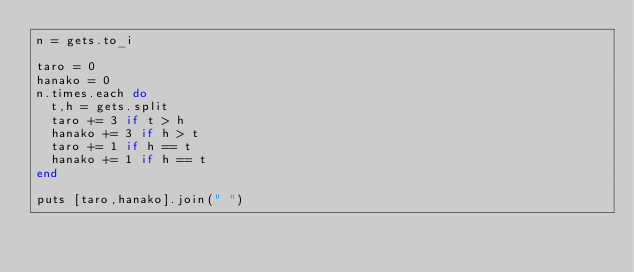Convert code to text. <code><loc_0><loc_0><loc_500><loc_500><_Ruby_>n = gets.to_i

taro = 0
hanako = 0
n.times.each do
  t,h = gets.split
  taro += 3 if t > h
  hanako += 3 if h > t
  taro += 1 if h == t
  hanako += 1 if h == t
end

puts [taro,hanako].join(" ")</code> 